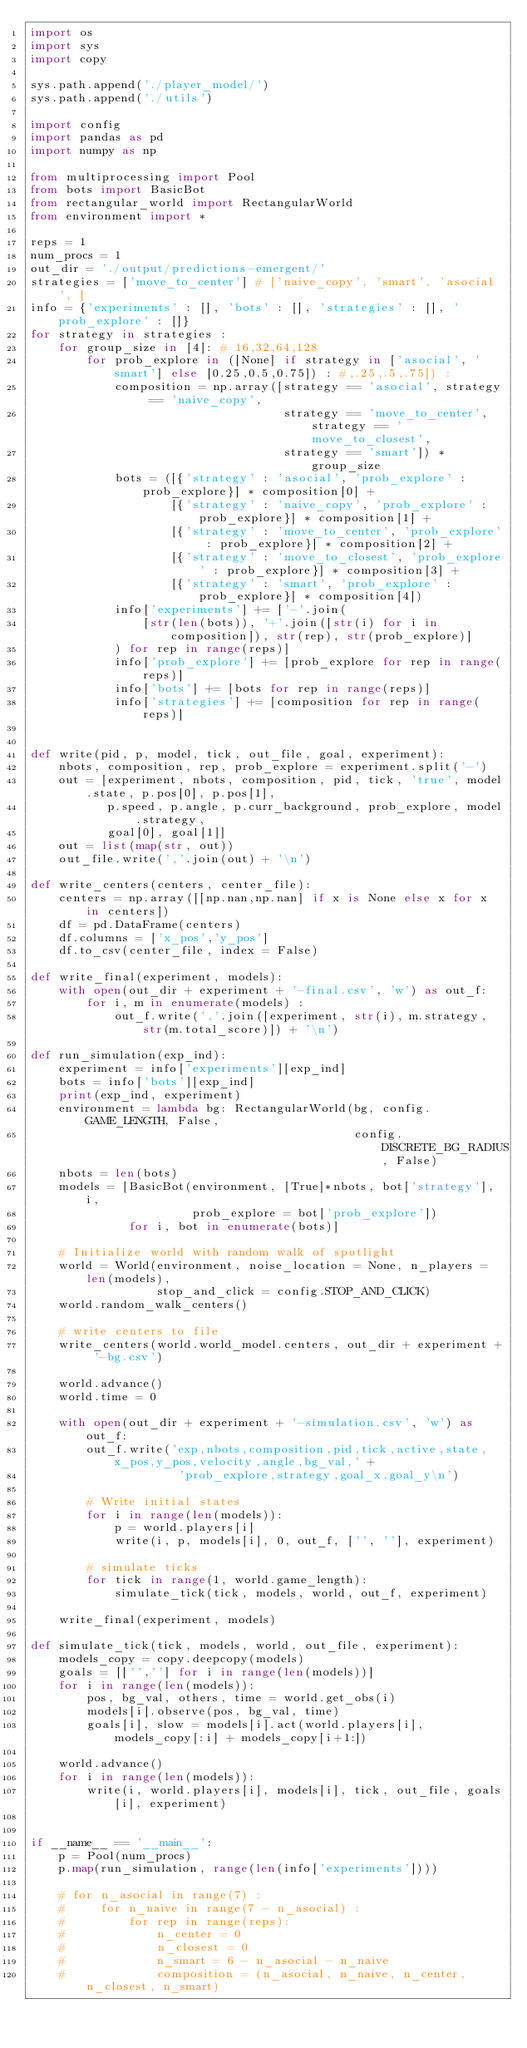<code> <loc_0><loc_0><loc_500><loc_500><_Python_>import os
import sys
import copy

sys.path.append('./player_model/')
sys.path.append('./utils')

import config
import pandas as pd
import numpy as np

from multiprocessing import Pool
from bots import BasicBot
from rectangular_world import RectangularWorld
from environment import *

reps = 1
num_procs = 1
out_dir = './output/predictions-emergent/'
strategies = ['move_to_center'] # ['naive_copy', 'smart', 'asocial', ]
info = {'experiments' : [], 'bots' : [], 'strategies' : [], 'prob_explore' : []}
for strategy in strategies :
    for group_size in [4]: # 16,32,64,128
        for prob_explore in ([None] if strategy in ['asocial', 'smart'] else [0.25,0.5,0.75]) : #,.25,.5,.75]) :
            composition = np.array([strategy == 'asocial', strategy == 'naive_copy',
                                    strategy == 'move_to_center', strategy == 'move_to_closest',
                                    strategy == 'smart']) * group_size
            bots = ([{'strategy' : 'asocial', 'prob_explore' : prob_explore}] * composition[0] +
                    [{'strategy' : 'naive_copy', 'prob_explore' : prob_explore}] * composition[1] +
                    [{'strategy' : 'move_to_center', 'prob_explore' : prob_explore}] * composition[2] +
                    [{'strategy' : 'move_to_closest', 'prob_explore' : prob_explore}] * composition[3] +
                    [{'strategy' : 'smart', 'prob_explore' : prob_explore}] * composition[4])
            info['experiments'] += ['-'.join(
                [str(len(bots)), '+'.join([str(i) for i in composition]), str(rep), str(prob_explore)]
            ) for rep in range(reps)]
            info['prob_explore'] += [prob_explore for rep in range(reps)]
            info['bots'] += [bots for rep in range(reps)]
            info['strategies'] += [composition for rep in range(reps)]


def write(pid, p, model, tick, out_file, goal, experiment):
    nbots, composition, rep, prob_explore = experiment.split('-')
    out = [experiment, nbots, composition, pid, tick, 'true', model.state, p.pos[0], p.pos[1],
           p.speed, p.angle, p.curr_background, prob_explore, model.strategy,
           goal[0], goal[1]]
    out = list(map(str, out))
    out_file.write(','.join(out) + '\n')

def write_centers(centers, center_file):    
    centers = np.array([[np.nan,np.nan] if x is None else x for x in centers])
    df = pd.DataFrame(centers)
    df.columns = ['x_pos','y_pos']
    df.to_csv(center_file, index = False)
    
def write_final(experiment, models):    
    with open(out_dir + experiment + '-final.csv', 'w') as out_f:
        for i, m in enumerate(models) :
            out_f.write(','.join([experiment, str(i), m.strategy, str(m.total_score)]) + '\n')

def run_simulation(exp_ind):
    experiment = info['experiments'][exp_ind]
    bots = info['bots'][exp_ind]
    print(exp_ind, experiment)
    environment = lambda bg: RectangularWorld(bg, config.GAME_LENGTH, False,
                                              config.DISCRETE_BG_RADIUS, False)
    nbots = len(bots)
    models = [BasicBot(environment, [True]*nbots, bot['strategy'], i,
                       prob_explore = bot['prob_explore'])
              for i, bot in enumerate(bots)]

    # Initialize world with random walk of spotlight
    world = World(environment, noise_location = None, n_players = len(models),
                  stop_and_click = config.STOP_AND_CLICK)
    world.random_walk_centers()

    # write centers to file
    write_centers(world.world_model.centers, out_dir + experiment + '-bg.csv')

    world.advance() 
    world.time = 0        

    with open(out_dir + experiment + '-simulation.csv', 'w') as out_f:
        out_f.write('exp,nbots,composition,pid,tick,active,state,x_pos,y_pos,velocity,angle,bg_val,' +
                     'prob_explore,strategy,goal_x,goal_y\n')

        # Write initial states
        for i in range(len(models)):
            p = world.players[i]
            write(i, p, models[i], 0, out_f, ['', ''], experiment)

        # simulate ticks
        for tick in range(1, world.game_length):
            simulate_tick(tick, models, world, out_f, experiment)

    write_final(experiment, models)
            
def simulate_tick(tick, models, world, out_file, experiment):
    models_copy = copy.deepcopy(models)
    goals = [['',''] for i in range(len(models))]
    for i in range(len(models)):        
        pos, bg_val, others, time = world.get_obs(i)
        models[i].observe(pos, bg_val, time)
        goals[i], slow = models[i].act(world.players[i], models_copy[:i] + models_copy[i+1:])
        
    world.advance()
    for i in range(len(models)):
        write(i, world.players[i], models[i], tick, out_file, goals[i], experiment)
    

if __name__ == '__main__':
    p = Pool(num_procs)
    p.map(run_simulation, range(len(info['experiments'])))

    # for n_asocial in range(7) :
    #     for n_naive in range(7 - n_asocial) :
    #         for rep in range(reps):
    #             n_center = 0
    #             n_closest = 0
    #             n_smart = 6 - n_asocial - n_naive
    #             composition = (n_asocial, n_naive, n_center, n_closest, n_smart)</code> 